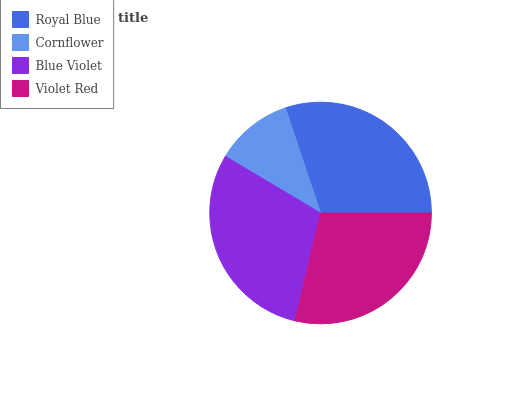Is Cornflower the minimum?
Answer yes or no. Yes. Is Royal Blue the maximum?
Answer yes or no. Yes. Is Blue Violet the minimum?
Answer yes or no. No. Is Blue Violet the maximum?
Answer yes or no. No. Is Blue Violet greater than Cornflower?
Answer yes or no. Yes. Is Cornflower less than Blue Violet?
Answer yes or no. Yes. Is Cornflower greater than Blue Violet?
Answer yes or no. No. Is Blue Violet less than Cornflower?
Answer yes or no. No. Is Blue Violet the high median?
Answer yes or no. Yes. Is Violet Red the low median?
Answer yes or no. Yes. Is Cornflower the high median?
Answer yes or no. No. Is Royal Blue the low median?
Answer yes or no. No. 